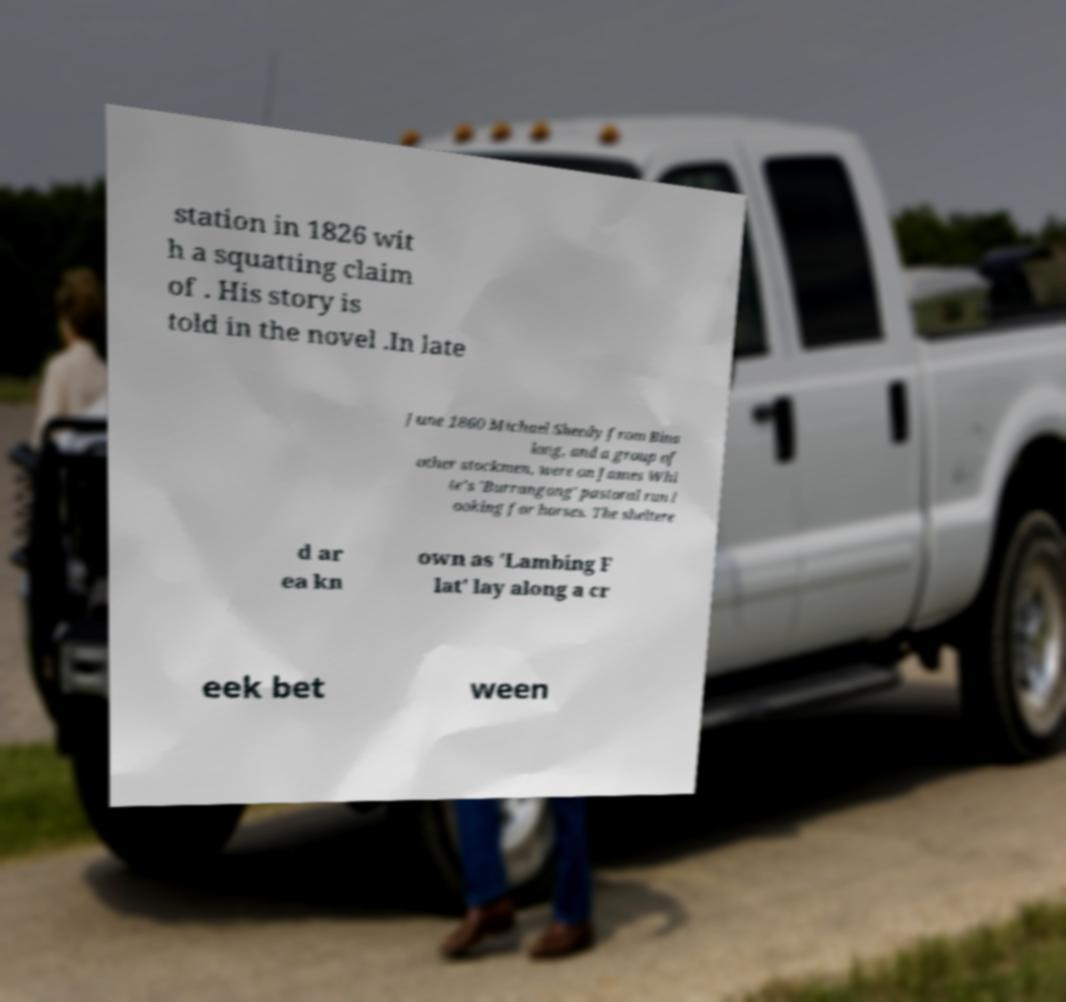I need the written content from this picture converted into text. Can you do that? station in 1826 wit h a squatting claim of . His story is told in the novel .In late June 1860 Michael Sheedy from Bina long, and a group of other stockmen, were on James Whi te’s 'Burrangong' pastoral run l ooking for horses. The sheltere d ar ea kn own as 'Lambing F lat' lay along a cr eek bet ween 